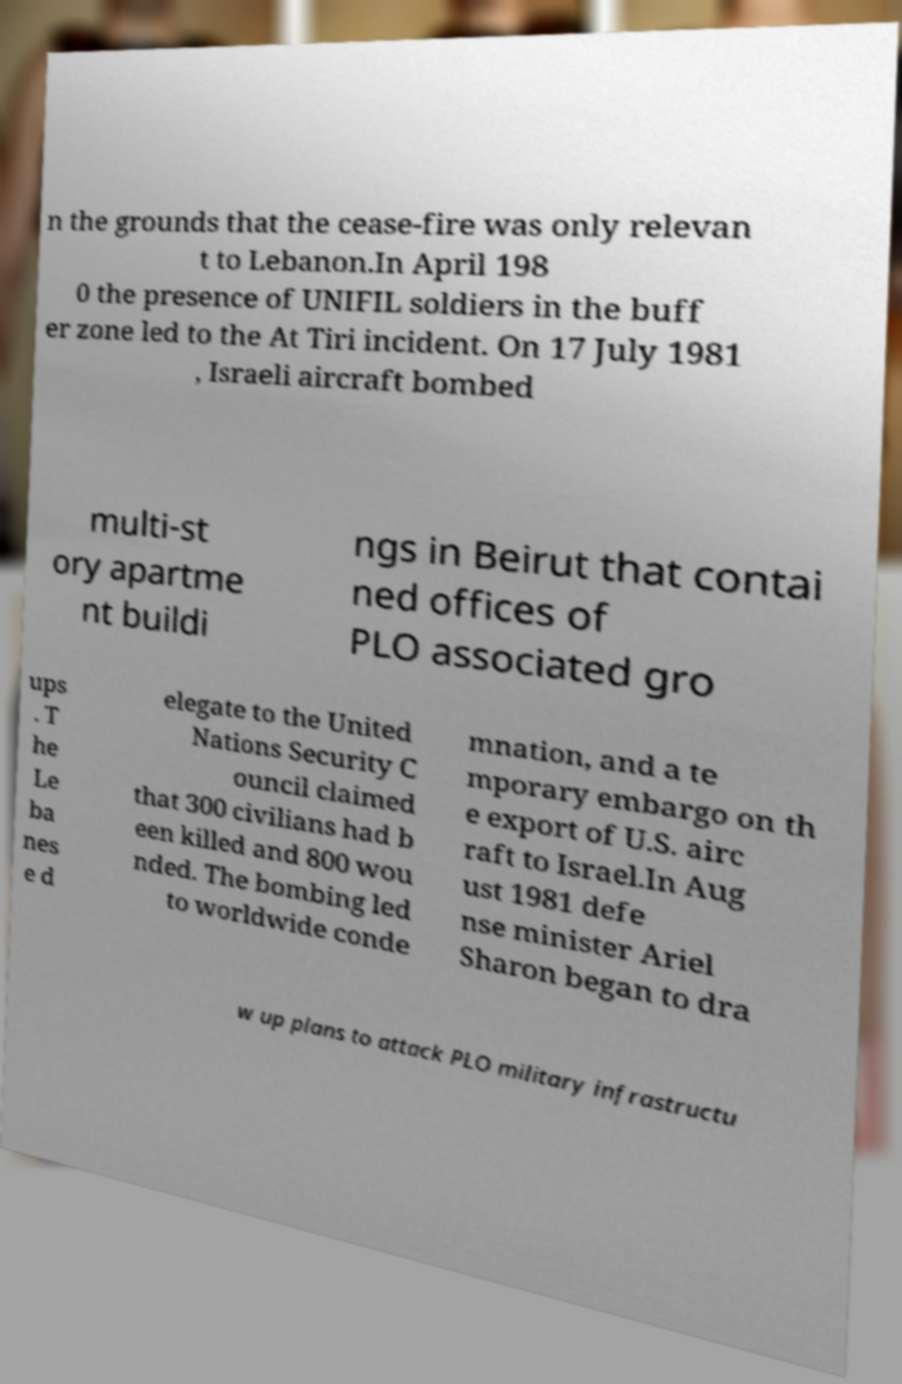Please read and relay the text visible in this image. What does it say? n the grounds that the cease-fire was only relevan t to Lebanon.In April 198 0 the presence of UNIFIL soldiers in the buff er zone led to the At Tiri incident. On 17 July 1981 , Israeli aircraft bombed multi-st ory apartme nt buildi ngs in Beirut that contai ned offices of PLO associated gro ups . T he Le ba nes e d elegate to the United Nations Security C ouncil claimed that 300 civilians had b een killed and 800 wou nded. The bombing led to worldwide conde mnation, and a te mporary embargo on th e export of U.S. airc raft to Israel.In Aug ust 1981 defe nse minister Ariel Sharon began to dra w up plans to attack PLO military infrastructu 